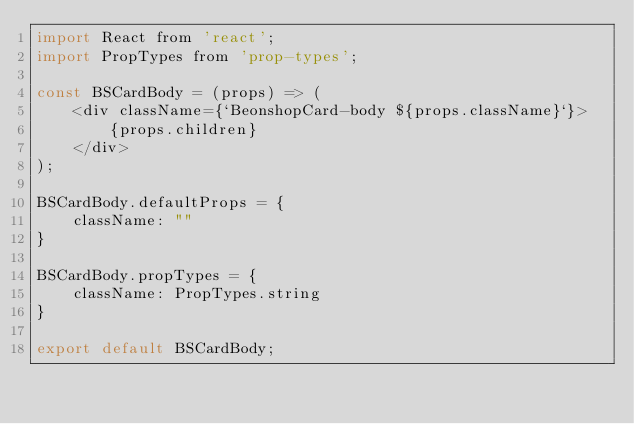<code> <loc_0><loc_0><loc_500><loc_500><_JavaScript_>import React from 'react';
import PropTypes from 'prop-types';

const BSCardBody = (props) => (
    <div className={`BeonshopCard-body ${props.className}`}>
        {props.children}
    </div>
);

BSCardBody.defaultProps = {
    className: ""
}

BSCardBody.propTypes = {
    className: PropTypes.string
}

export default BSCardBody;</code> 